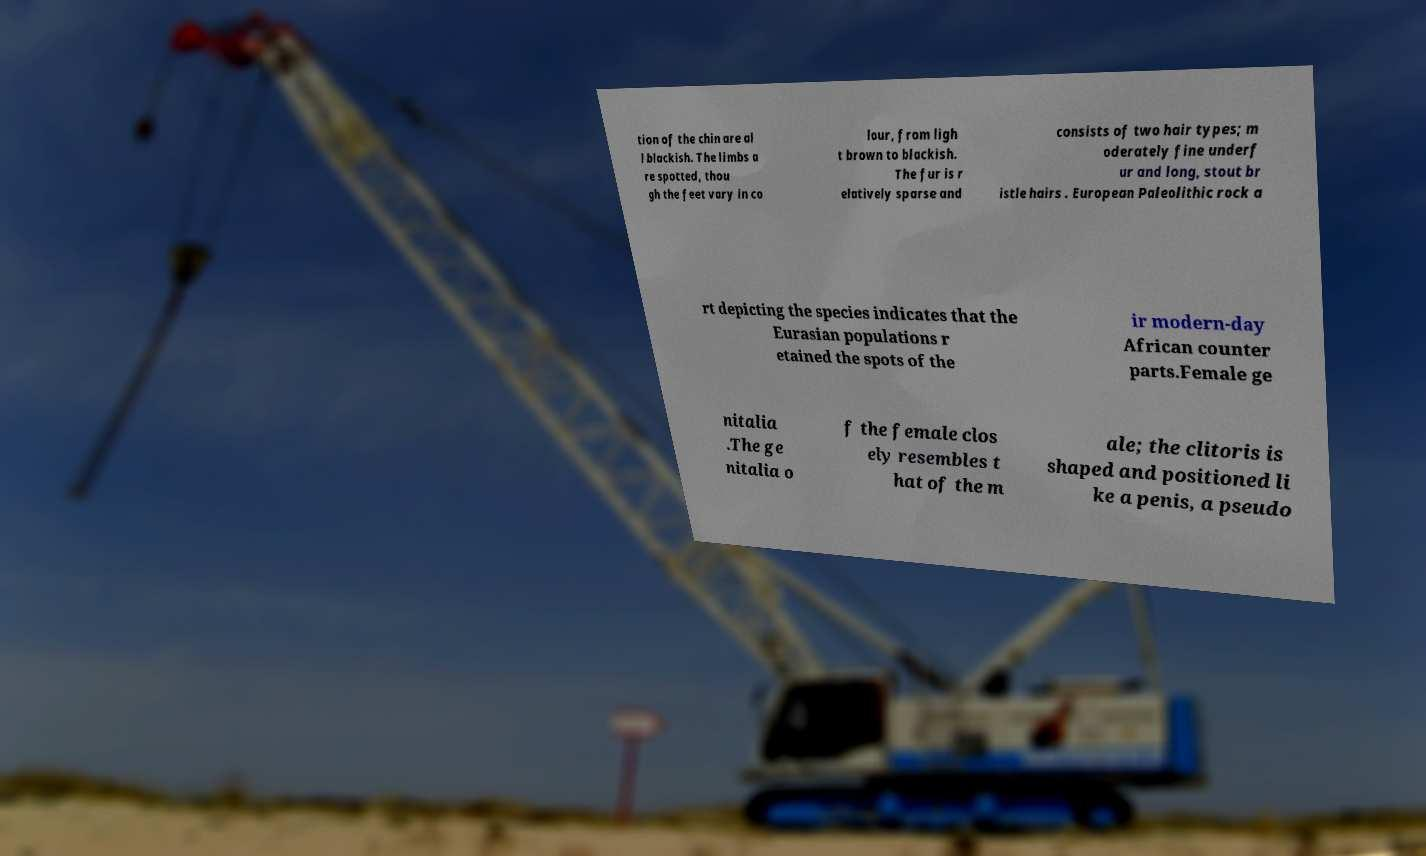Can you read and provide the text displayed in the image?This photo seems to have some interesting text. Can you extract and type it out for me? tion of the chin are al l blackish. The limbs a re spotted, thou gh the feet vary in co lour, from ligh t brown to blackish. The fur is r elatively sparse and consists of two hair types; m oderately fine underf ur and long, stout br istle hairs . European Paleolithic rock a rt depicting the species indicates that the Eurasian populations r etained the spots of the ir modern-day African counter parts.Female ge nitalia .The ge nitalia o f the female clos ely resembles t hat of the m ale; the clitoris is shaped and positioned li ke a penis, a pseudo 